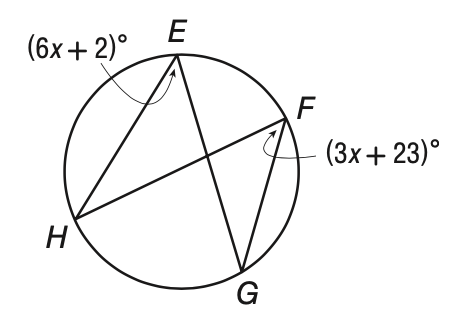Question: Solve for x in the figure below.
Choices:
A. 4
B. 5
C. 6
D. 7
Answer with the letter. Answer: D 